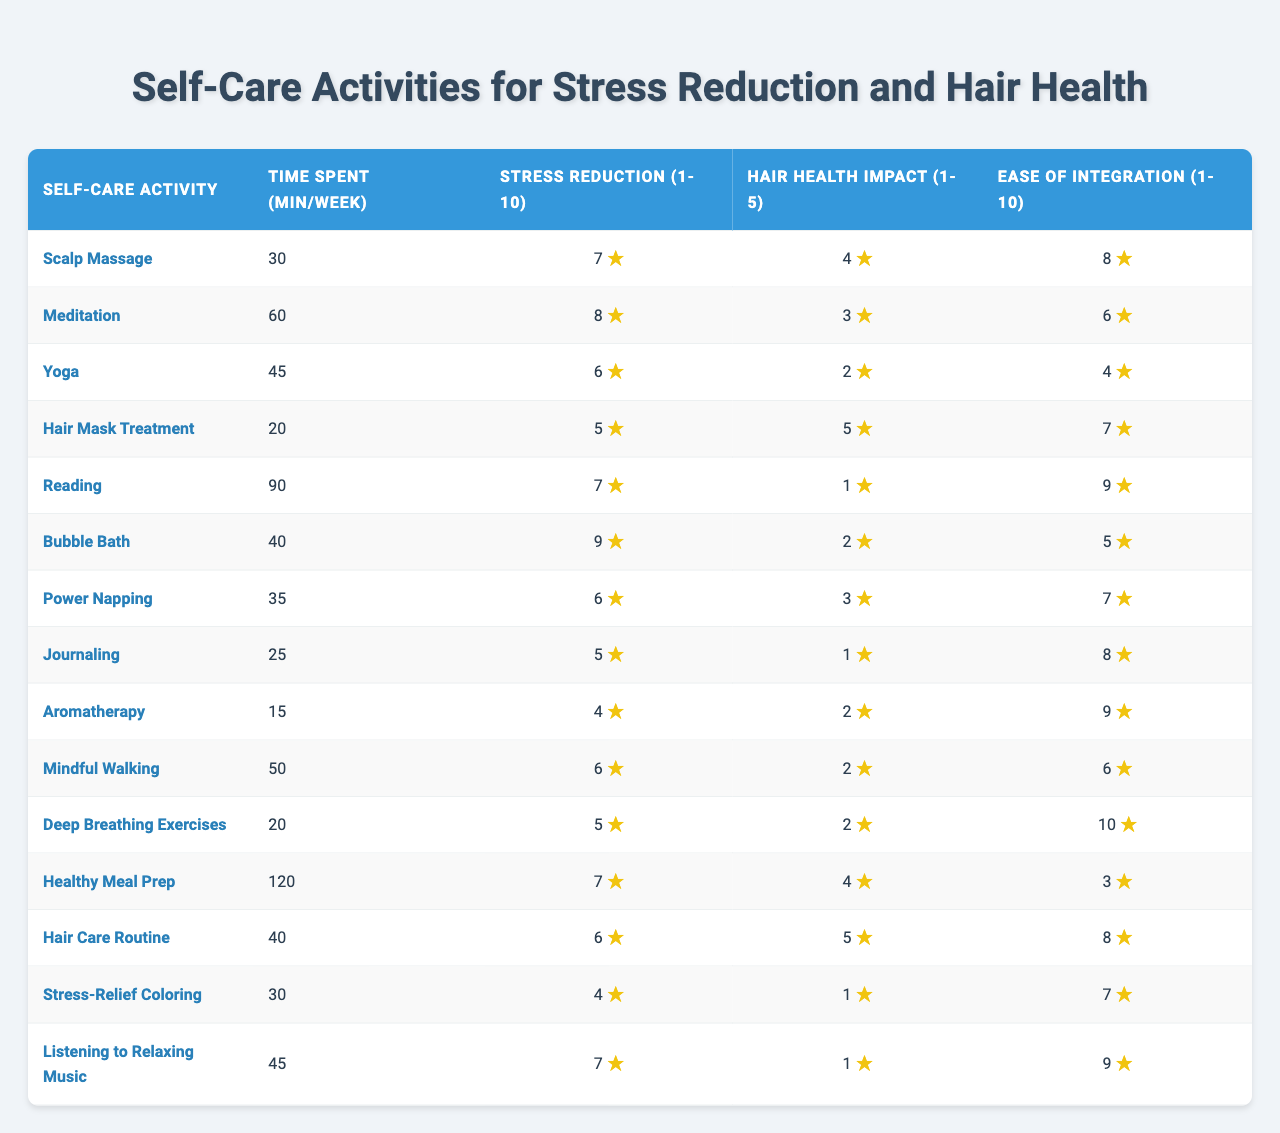What self-care activity has the highest perceived stress reduction score? By examining the "Perceived Stress Reduction" column, we can see that "Meditation" has the highest score of 8.
Answer: Meditation Which self-care activity requires the least time commitment per week? Looking at the "Time Spent" column, "Hair Mask Treatment" requires the least amount of time at 20 minutes per week.
Answer: Hair Mask Treatment What is the average time spent on self-care activities per week? To find the average, we sum the time spent values: (30 + 60 + 45 + 20 + 90 + 40 + 35 + 25 + 15 + 50 + 20 + 120 + 40 + 30 + 45) =  605 minutes. There are 15 activities, so the average is 605 / 15 = 40.33 minutes.
Answer: 40.33 minutes Which activity has the greatest impact on hair health? We check the "Impact on Hair Health" column, where "Hair Mask Treatment" and "Healthy Meal Prep" both have a score of 5, making them the activities with the greatest impact.
Answer: Hair Mask Treatment, Healthy Meal Prep Is there a self-care activity that scores 10 on the ease of integration scale? Reviewing the "Ease of Integration" column, we find no activities with a score of 10, as the highest score is 10 for "Healthy Meal Prep."
Answer: No Which activity balances high time spent and a good stress reduction score? By comparing time spent and stress reduction, "Yoga" takes 45 minutes and provides a stress reduction score of 6; this indicates a reasonable balance.
Answer: Yoga How many activities scored above a perceived stress reduction of 7? Checking the "Perceived Stress Reduction" column, four activities exceed a score of 7: "Meditation," "Bubble Bath," "Healthy Meal Prep," and "Listening to Relaxing Music." Therefore, the answer is 4 activities.
Answer: 4 activities What is the sum of ease of integration scores for all self-care activities? We sum the "Ease of Integration" scores: (8 + 6 + 4 + 7 + 9 + 5 + 7 + 8 + 9 + 6 + 10 + 3 + 8 + 7 + 9) =  6.33
Answer: 115 Find the self-care activity with the lowest impact on hair health and explain its scores. "Reading" has the lowest impact on hair health with a score of 1. Its stress reduction score is 7, and the time spent is 90 minutes, indicating it’s not effective for hair health despite providing some stress relief.
Answer: Reading Which self-care activity is easiest to integrate but has a low perceived stress reduction score? "Deep Breathing Exercises" score 10 for ease of integration but only 6 for perceived stress reduction. This shows that while it's easy to fit into a work week, it may not effectively reduce stress.
Answer: Deep Breathing Exercises 